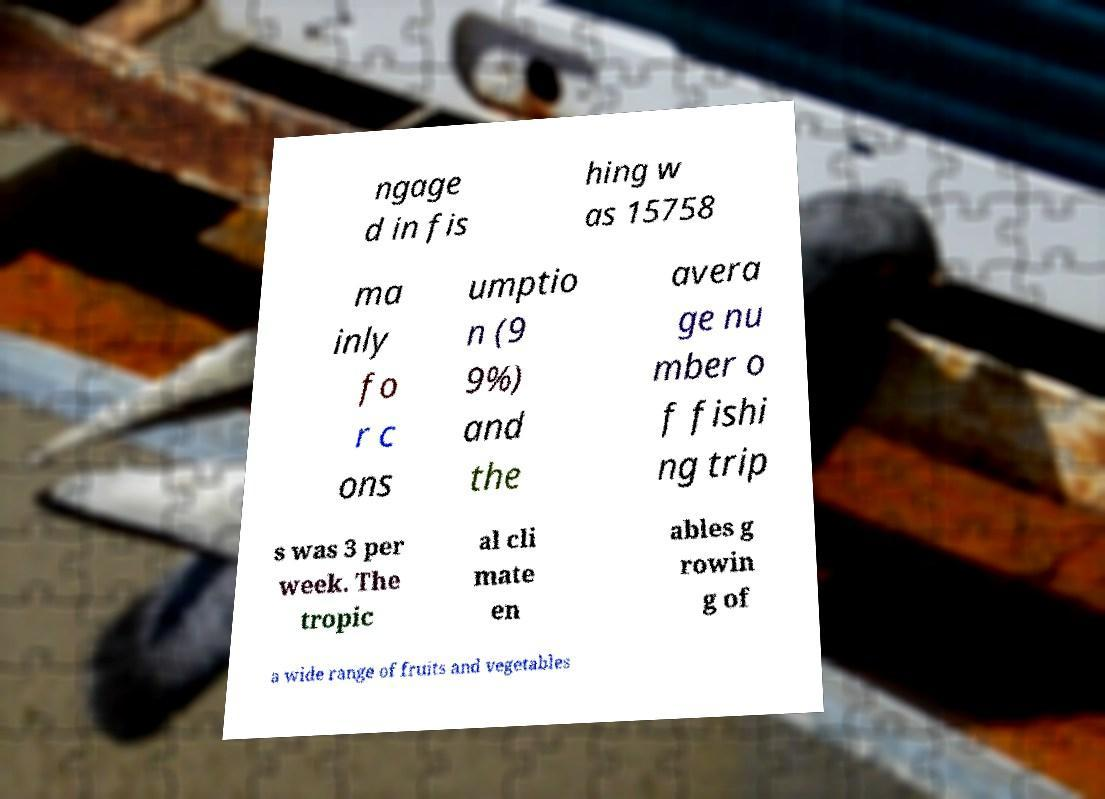Can you accurately transcribe the text from the provided image for me? ngage d in fis hing w as 15758 ma inly fo r c ons umptio n (9 9%) and the avera ge nu mber o f fishi ng trip s was 3 per week. The tropic al cli mate en ables g rowin g of a wide range of fruits and vegetables 